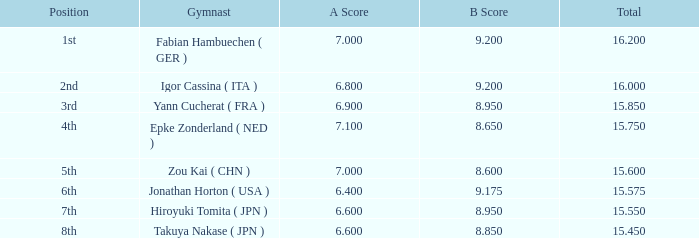65? None. 